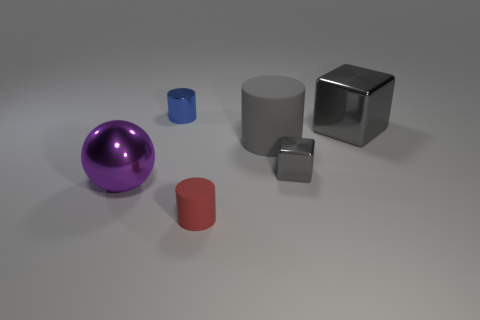Do the metallic cube in front of the big shiny cube and the big object behind the gray matte cylinder have the same color?
Offer a terse response. Yes. Do the cylinder on the left side of the red rubber cylinder and the tiny thing that is right of the red matte thing have the same material?
Provide a succinct answer. Yes. What number of red cylinders have the same size as the red thing?
Your answer should be very brief. 0. Are there fewer gray metal cubes than large objects?
Offer a terse response. Yes. What shape is the small thing in front of the large thing that is to the left of the tiny red rubber cylinder?
Your answer should be very brief. Cylinder. The other metal object that is the same size as the blue shiny thing is what shape?
Keep it short and to the point. Cube. Are there any tiny metallic objects of the same shape as the small red matte thing?
Your answer should be very brief. Yes. What is the large purple sphere made of?
Offer a very short reply. Metal. There is a large ball; are there any red cylinders right of it?
Your response must be concise. Yes. There is a small cylinder that is behind the big sphere; how many big metallic objects are left of it?
Your answer should be very brief. 1. 